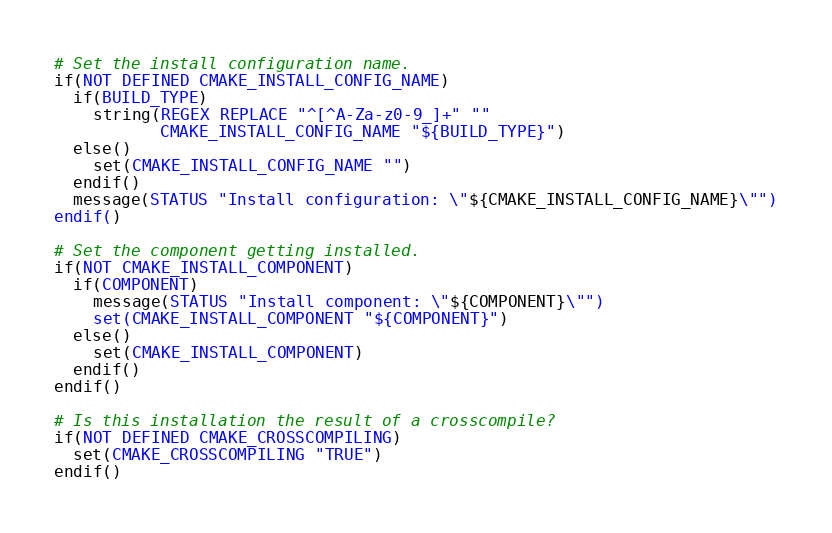Convert code to text. <code><loc_0><loc_0><loc_500><loc_500><_CMake_># Set the install configuration name.
if(NOT DEFINED CMAKE_INSTALL_CONFIG_NAME)
  if(BUILD_TYPE)
    string(REGEX REPLACE "^[^A-Za-z0-9_]+" ""
           CMAKE_INSTALL_CONFIG_NAME "${BUILD_TYPE}")
  else()
    set(CMAKE_INSTALL_CONFIG_NAME "")
  endif()
  message(STATUS "Install configuration: \"${CMAKE_INSTALL_CONFIG_NAME}\"")
endif()

# Set the component getting installed.
if(NOT CMAKE_INSTALL_COMPONENT)
  if(COMPONENT)
    message(STATUS "Install component: \"${COMPONENT}\"")
    set(CMAKE_INSTALL_COMPONENT "${COMPONENT}")
  else()
    set(CMAKE_INSTALL_COMPONENT)
  endif()
endif()

# Is this installation the result of a crosscompile?
if(NOT DEFINED CMAKE_CROSSCOMPILING)
  set(CMAKE_CROSSCOMPILING "TRUE")
endif()

</code> 